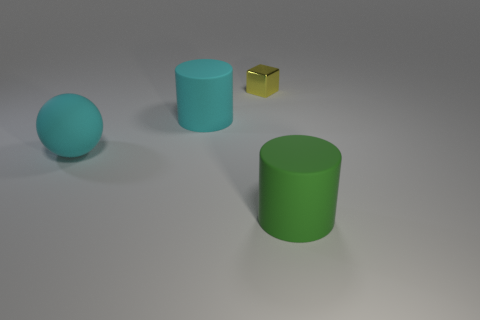What is the shape of the cyan object that is the same size as the cyan sphere?
Give a very brief answer. Cylinder. The tiny thing has what shape?
Offer a very short reply. Cube. Does the big cylinder that is behind the big green matte object have the same material as the big ball?
Offer a terse response. Yes. What size is the matte thing that is on the left side of the matte thing behind the large sphere?
Your response must be concise. Large. There is a large rubber thing that is to the right of the ball and behind the green rubber cylinder; what is its color?
Keep it short and to the point. Cyan. There is a green thing that is the same size as the cyan sphere; what is it made of?
Your response must be concise. Rubber. What number of other objects are the same material as the green cylinder?
Provide a short and direct response. 2. Do the rubber cylinder on the right side of the metallic object and the matte cylinder that is left of the tiny yellow shiny object have the same color?
Your answer should be compact. No. There is a tiny metal thing left of the large rubber thing that is on the right side of the small metal block; what shape is it?
Make the answer very short. Cube. What number of other objects are there of the same color as the small cube?
Ensure brevity in your answer.  0. 